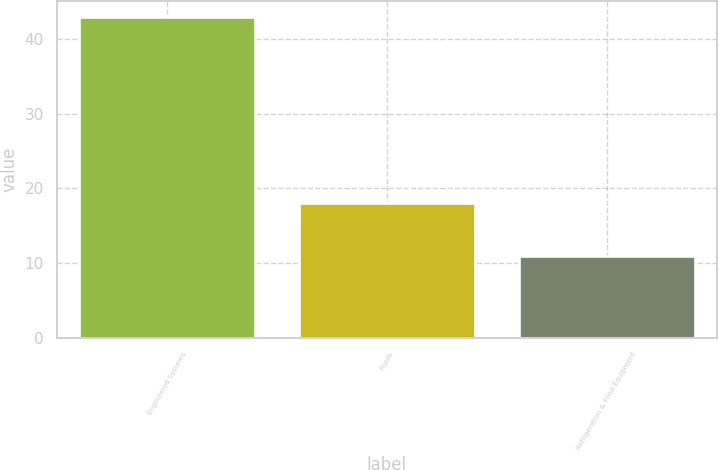<chart> <loc_0><loc_0><loc_500><loc_500><bar_chart><fcel>Engineered Systems<fcel>Fluids<fcel>Refrigeration & Food Equipment<nl><fcel>43<fcel>18<fcel>11<nl></chart> 